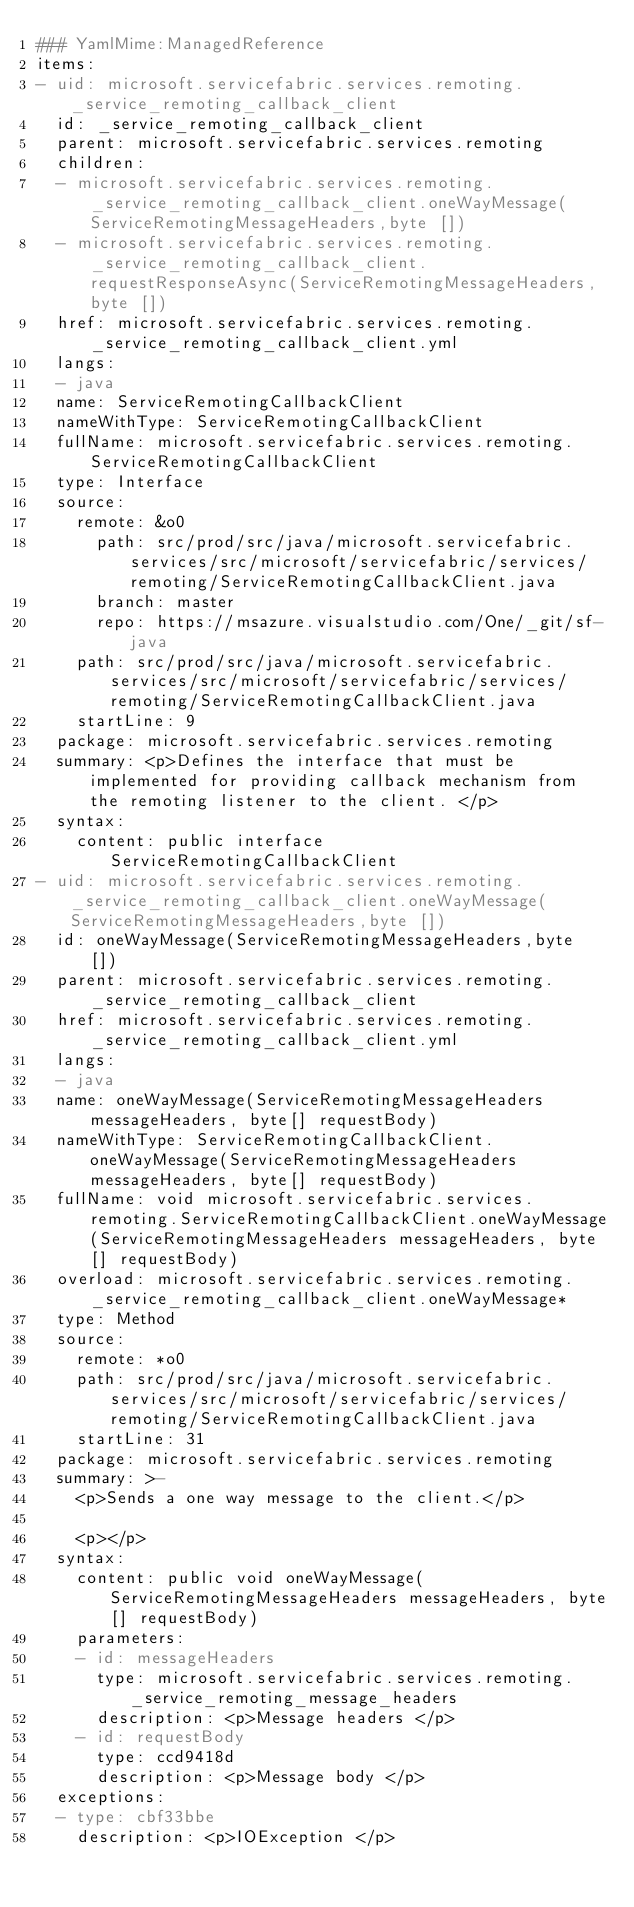<code> <loc_0><loc_0><loc_500><loc_500><_YAML_>### YamlMime:ManagedReference
items:
- uid: microsoft.servicefabric.services.remoting._service_remoting_callback_client
  id: _service_remoting_callback_client
  parent: microsoft.servicefabric.services.remoting
  children:
  - microsoft.servicefabric.services.remoting._service_remoting_callback_client.oneWayMessage(ServiceRemotingMessageHeaders,byte [])
  - microsoft.servicefabric.services.remoting._service_remoting_callback_client.requestResponseAsync(ServiceRemotingMessageHeaders,byte [])
  href: microsoft.servicefabric.services.remoting._service_remoting_callback_client.yml
  langs:
  - java
  name: ServiceRemotingCallbackClient
  nameWithType: ServiceRemotingCallbackClient
  fullName: microsoft.servicefabric.services.remoting.ServiceRemotingCallbackClient
  type: Interface
  source:
    remote: &o0
      path: src/prod/src/java/microsoft.servicefabric.services/src/microsoft/servicefabric/services/remoting/ServiceRemotingCallbackClient.java
      branch: master
      repo: https://msazure.visualstudio.com/One/_git/sf-java
    path: src/prod/src/java/microsoft.servicefabric.services/src/microsoft/servicefabric/services/remoting/ServiceRemotingCallbackClient.java
    startLine: 9
  package: microsoft.servicefabric.services.remoting
  summary: <p>Defines the interface that must be implemented for providing callback mechanism from the remoting listener to the client. </p>
  syntax:
    content: public interface ServiceRemotingCallbackClient
- uid: microsoft.servicefabric.services.remoting._service_remoting_callback_client.oneWayMessage(ServiceRemotingMessageHeaders,byte [])
  id: oneWayMessage(ServiceRemotingMessageHeaders,byte [])
  parent: microsoft.servicefabric.services.remoting._service_remoting_callback_client
  href: microsoft.servicefabric.services.remoting._service_remoting_callback_client.yml
  langs:
  - java
  name: oneWayMessage(ServiceRemotingMessageHeaders messageHeaders, byte[] requestBody)
  nameWithType: ServiceRemotingCallbackClient.oneWayMessage(ServiceRemotingMessageHeaders messageHeaders, byte[] requestBody)
  fullName: void microsoft.servicefabric.services.remoting.ServiceRemotingCallbackClient.oneWayMessage(ServiceRemotingMessageHeaders messageHeaders, byte[] requestBody)
  overload: microsoft.servicefabric.services.remoting._service_remoting_callback_client.oneWayMessage*
  type: Method
  source:
    remote: *o0
    path: src/prod/src/java/microsoft.servicefabric.services/src/microsoft/servicefabric/services/remoting/ServiceRemotingCallbackClient.java
    startLine: 31
  package: microsoft.servicefabric.services.remoting
  summary: >-
    <p>Sends a one way message to the client.</p>

    <p></p>
  syntax:
    content: public void oneWayMessage(ServiceRemotingMessageHeaders messageHeaders, byte[] requestBody)
    parameters:
    - id: messageHeaders
      type: microsoft.servicefabric.services.remoting._service_remoting_message_headers
      description: <p>Message headers </p>
    - id: requestBody
      type: ccd9418d
      description: <p>Message body </p>
  exceptions:
  - type: cbf33bbe
    description: <p>IOException </p></code> 